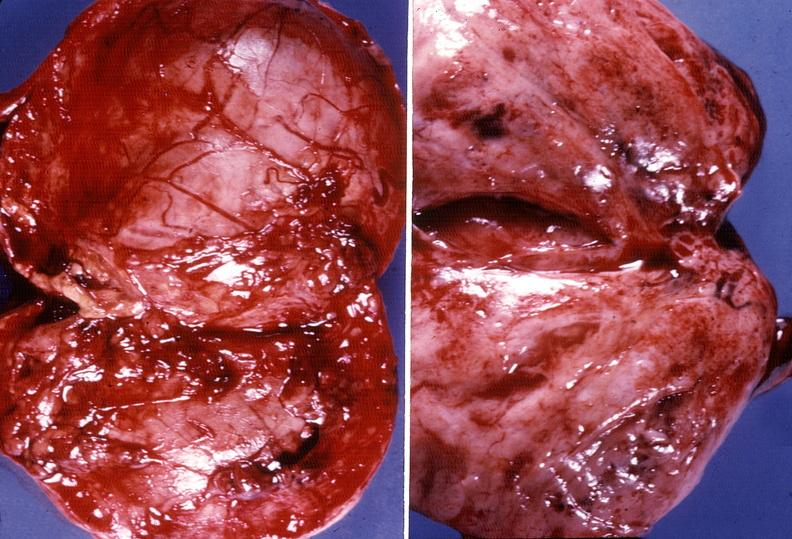s endocrine present?
Answer the question using a single word or phrase. Yes 